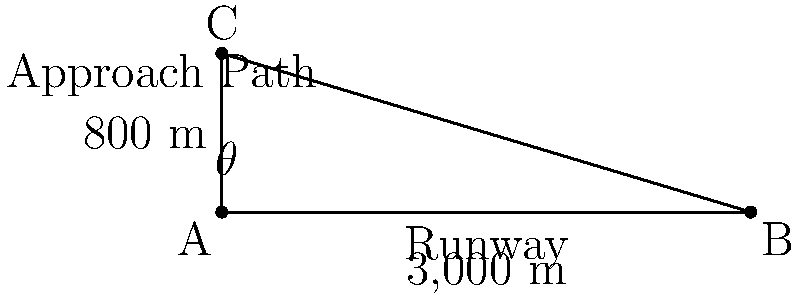As part of a cost-reduction initiative, you're evaluating the feasibility of using a shorter runway for certain aircraft. The current runway is 3,000 meters long, and the standard approach angle ($\theta$) results in aircraft reaching an altitude of 800 meters at the start of the runway. What is the approach angle ($\theta$) in degrees? How would reducing this angle impact operational costs and safety? Let's approach this step-by-step:

1) We can use trigonometry to solve for the angle $\theta$. The runway forms the base of a right-angled triangle, and the altitude at the start of the runway forms the opposite side.

2) We know:
   - The length of the runway (adjacent side) = 3,000 m
   - The altitude at the start of the runway (opposite side) = 800 m

3) We can use the tangent function to find the angle:

   $$\tan(\theta) = \frac{\text{opposite}}{\text{adjacent}} = \frac{800}{3000}$$

4) To solve for $\theta$, we take the inverse tangent (arctan or $\tan^{-1}$):

   $$\theta = \tan^{-1}(\frac{800}{3000})$$

5) Using a calculator or computer:

   $$\theta \approx 14.93^\circ$$

6) Regarding operational costs and safety:

   - Reducing this angle would allow aircraft to approach at a shallower angle, potentially reducing fuel consumption during the final approach.
   - However, a shallower angle means aircraft would be closer to the ground for a longer period, which could increase risks in case of unexpected events or adverse weather conditions.
   - A shallower angle might require longer runways for safe landings, potentially increasing infrastructure costs.
   - It could also increase noise pollution in areas further from the airport as aircraft would be flying at lower altitudes for longer distances.

The optimal approach angle balances these factors, considering fuel efficiency, safety margins, infrastructure requirements, and environmental impact.
Answer: $14.93^\circ$ 